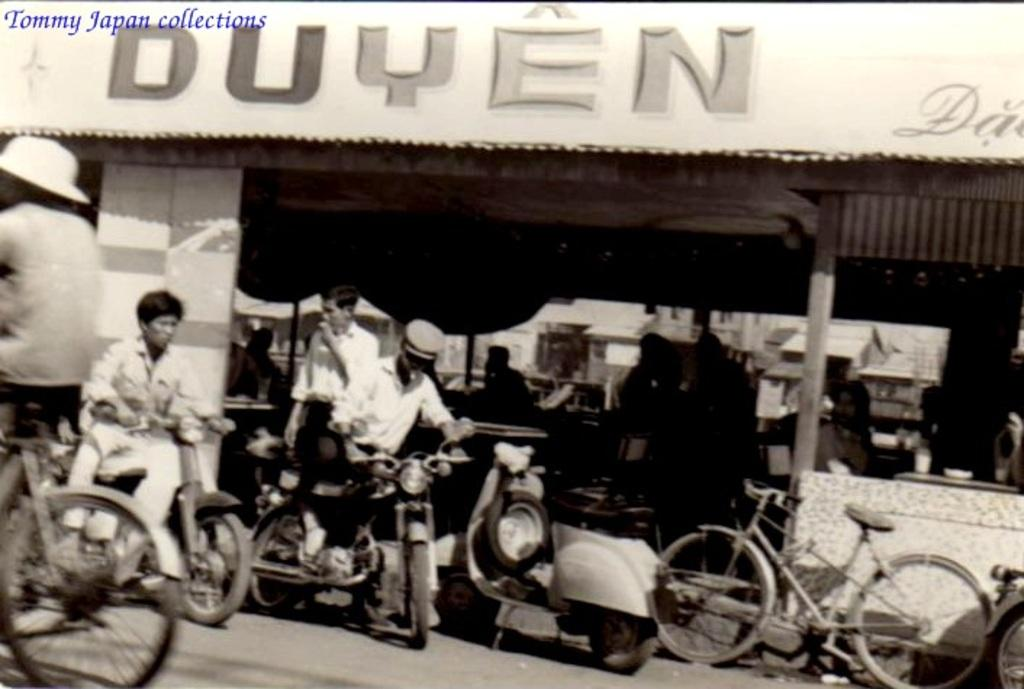What can be seen on the road in the image? There are vehicles on the road in the image. What are the people in the image doing? The people in the image are sitting on chairs. What is the large sign in the image? There is a hoarding in the image. Can you tell me what type of fiction is being read by the donkey in the image? There is no donkey or fiction present in the image. What time of day is it during the recess in the image? There is no recess depicted in the image. 